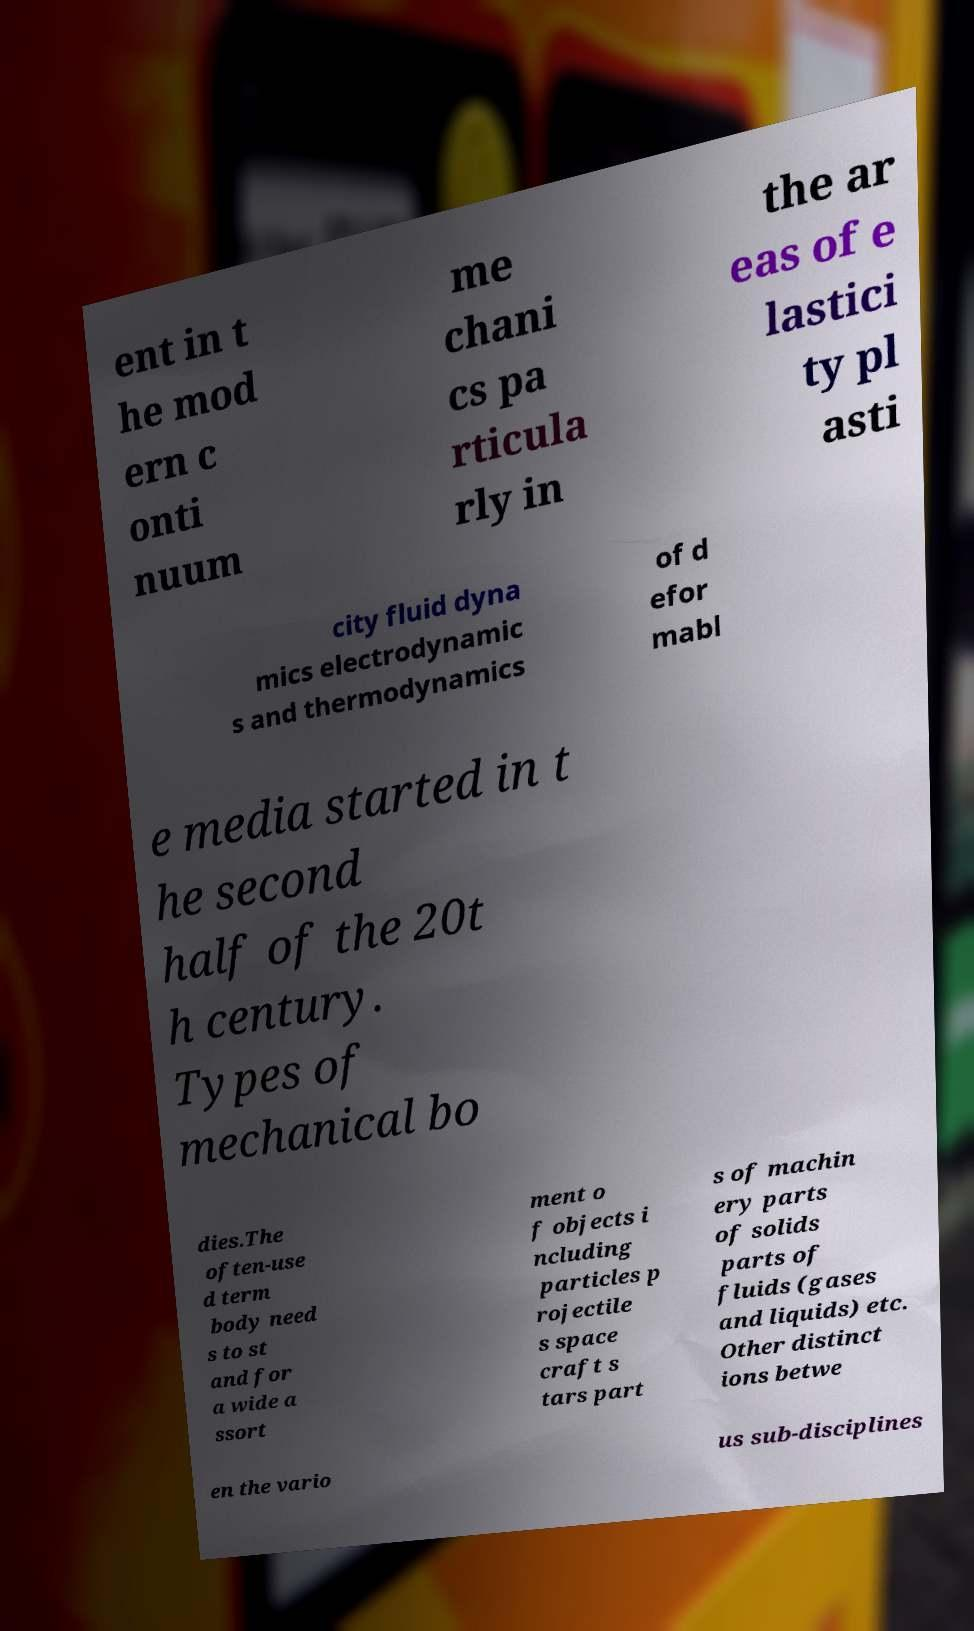Can you read and provide the text displayed in the image?This photo seems to have some interesting text. Can you extract and type it out for me? ent in t he mod ern c onti nuum me chani cs pa rticula rly in the ar eas of e lastici ty pl asti city fluid dyna mics electrodynamic s and thermodynamics of d efor mabl e media started in t he second half of the 20t h century. Types of mechanical bo dies.The often-use d term body need s to st and for a wide a ssort ment o f objects i ncluding particles p rojectile s space craft s tars part s of machin ery parts of solids parts of fluids (gases and liquids) etc. Other distinct ions betwe en the vario us sub-disciplines 